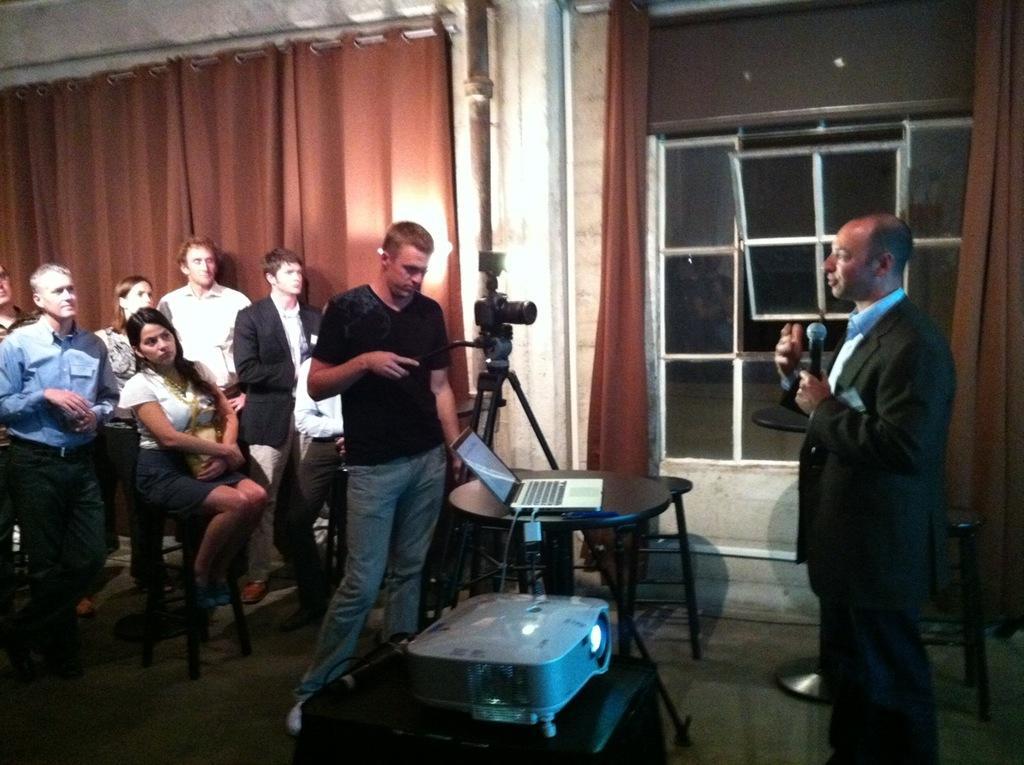In one or two sentences, can you explain what this image depicts? In the image we can see there are people who are standing and there is a woman who is sitting on chair and they are looking at a person who is standing and holding mic in his hand and there is a laptop on table. 